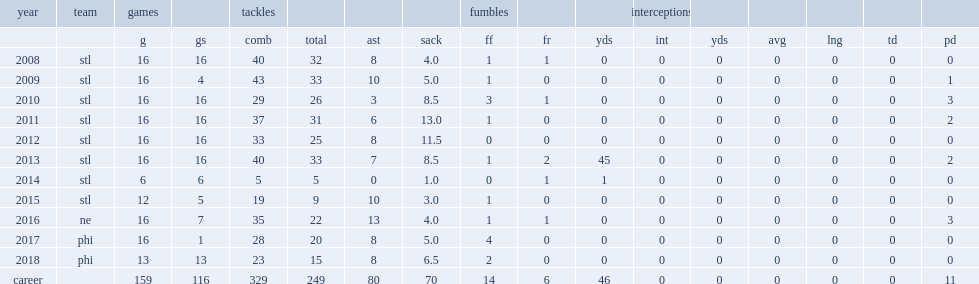How many sacks did long get in 2012? 11.5. 